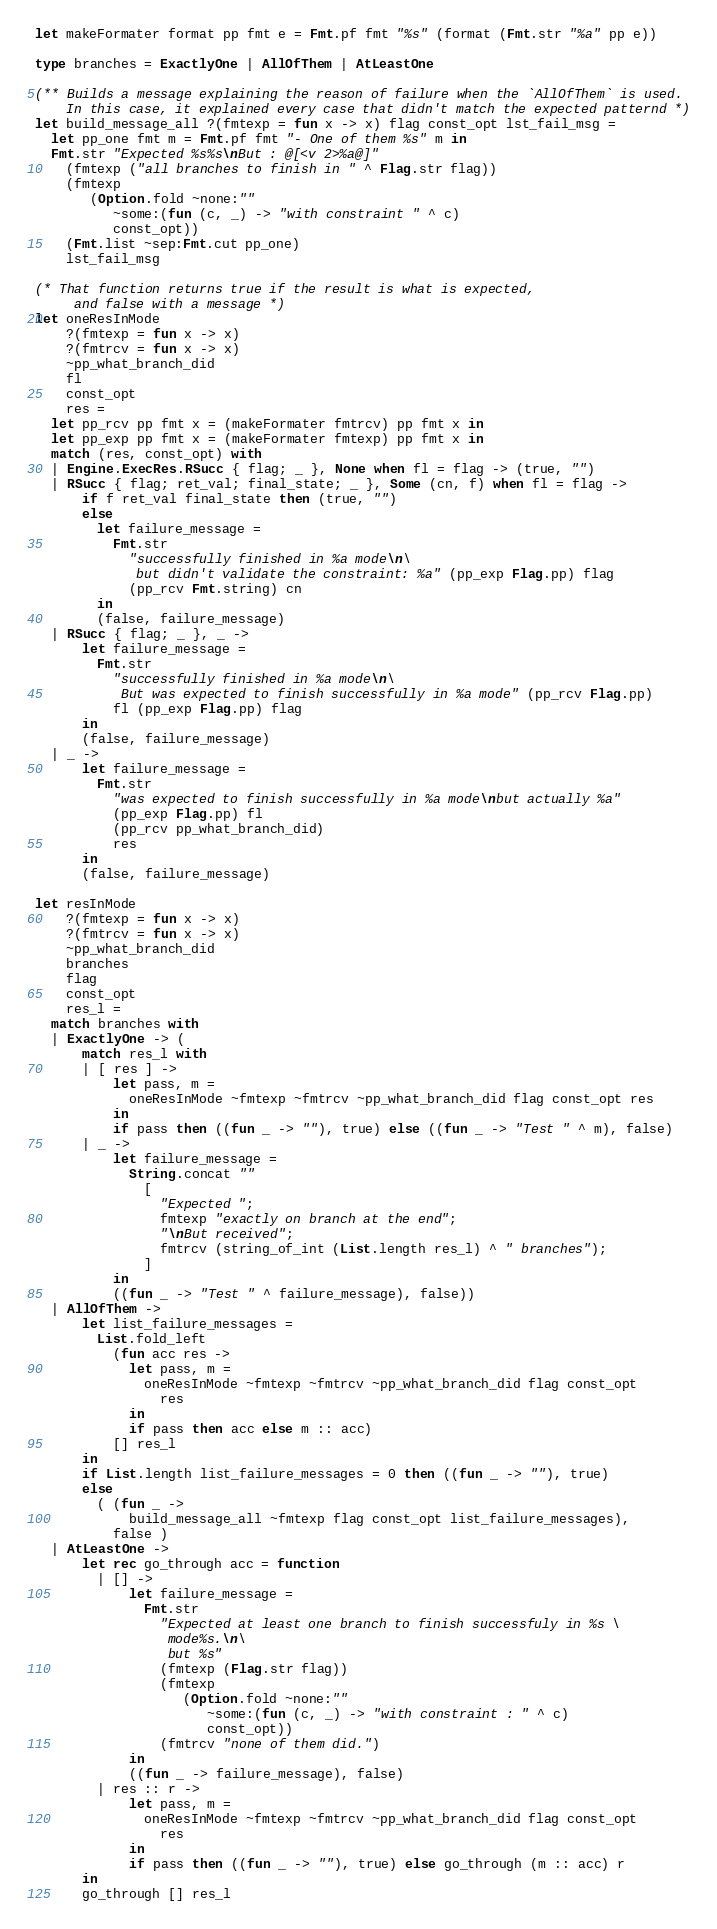Convert code to text. <code><loc_0><loc_0><loc_500><loc_500><_OCaml_>let makeFormater format pp fmt e = Fmt.pf fmt "%s" (format (Fmt.str "%a" pp e))

type branches = ExactlyOne | AllOfThem | AtLeastOne

(** Builds a message explaining the reason of failure when the `AllOfThem` is used.
    In this case, it explained every case that didn't match the expected patternd *)
let build_message_all ?(fmtexp = fun x -> x) flag const_opt lst_fail_msg =
  let pp_one fmt m = Fmt.pf fmt "- One of them %s" m in
  Fmt.str "Expected %s%s\nBut : @[<v 2>%a@]"
    (fmtexp ("all branches to finish in " ^ Flag.str flag))
    (fmtexp
       (Option.fold ~none:""
          ~some:(fun (c, _) -> "with constraint " ^ c)
          const_opt))
    (Fmt.list ~sep:Fmt.cut pp_one)
    lst_fail_msg

(* That function returns true if the result is what is expected,
     and false with a message *)
let oneResInMode
    ?(fmtexp = fun x -> x)
    ?(fmtrcv = fun x -> x)
    ~pp_what_branch_did
    fl
    const_opt
    res =
  let pp_rcv pp fmt x = (makeFormater fmtrcv) pp fmt x in
  let pp_exp pp fmt x = (makeFormater fmtexp) pp fmt x in
  match (res, const_opt) with
  | Engine.ExecRes.RSucc { flag; _ }, None when fl = flag -> (true, "")
  | RSucc { flag; ret_val; final_state; _ }, Some (cn, f) when fl = flag ->
      if f ret_val final_state then (true, "")
      else
        let failure_message =
          Fmt.str
            "successfully finished in %a mode\n\
             but didn't validate the constraint: %a" (pp_exp Flag.pp) flag
            (pp_rcv Fmt.string) cn
        in
        (false, failure_message)
  | RSucc { flag; _ }, _ ->
      let failure_message =
        Fmt.str
          "successfully finished in %a mode\n\
           But was expected to finish successfully in %a mode" (pp_rcv Flag.pp)
          fl (pp_exp Flag.pp) flag
      in
      (false, failure_message)
  | _ ->
      let failure_message =
        Fmt.str
          "was expected to finish successfully in %a mode\nbut actually %a"
          (pp_exp Flag.pp) fl
          (pp_rcv pp_what_branch_did)
          res
      in
      (false, failure_message)

let resInMode
    ?(fmtexp = fun x -> x)
    ?(fmtrcv = fun x -> x)
    ~pp_what_branch_did
    branches
    flag
    const_opt
    res_l =
  match branches with
  | ExactlyOne -> (
      match res_l with
      | [ res ] ->
          let pass, m =
            oneResInMode ~fmtexp ~fmtrcv ~pp_what_branch_did flag const_opt res
          in
          if pass then ((fun _ -> ""), true) else ((fun _ -> "Test " ^ m), false)
      | _ ->
          let failure_message =
            String.concat ""
              [
                "Expected ";
                fmtexp "exactly on branch at the end";
                "\nBut received";
                fmtrcv (string_of_int (List.length res_l) ^ " branches");
              ]
          in
          ((fun _ -> "Test " ^ failure_message), false))
  | AllOfThem ->
      let list_failure_messages =
        List.fold_left
          (fun acc res ->
            let pass, m =
              oneResInMode ~fmtexp ~fmtrcv ~pp_what_branch_did flag const_opt
                res
            in
            if pass then acc else m :: acc)
          [] res_l
      in
      if List.length list_failure_messages = 0 then ((fun _ -> ""), true)
      else
        ( (fun _ ->
            build_message_all ~fmtexp flag const_opt list_failure_messages),
          false )
  | AtLeastOne ->
      let rec go_through acc = function
        | [] ->
            let failure_message =
              Fmt.str
                "Expected at least one branch to finish successfuly in %s \
                 mode%s.\n\
                 but %s"
                (fmtexp (Flag.str flag))
                (fmtexp
                   (Option.fold ~none:""
                      ~some:(fun (c, _) -> "with constraint : " ^ c)
                      const_opt))
                (fmtrcv "none of them did.")
            in
            ((fun _ -> failure_message), false)
        | res :: r ->
            let pass, m =
              oneResInMode ~fmtexp ~fmtrcv ~pp_what_branch_did flag const_opt
                res
            in
            if pass then ((fun _ -> ""), true) else go_through (m :: acc) r
      in
      go_through [] res_l
</code> 